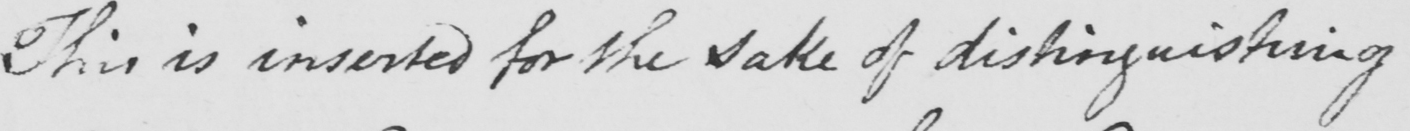Please provide the text content of this handwritten line. This is inserted for the sake of distinguishing 